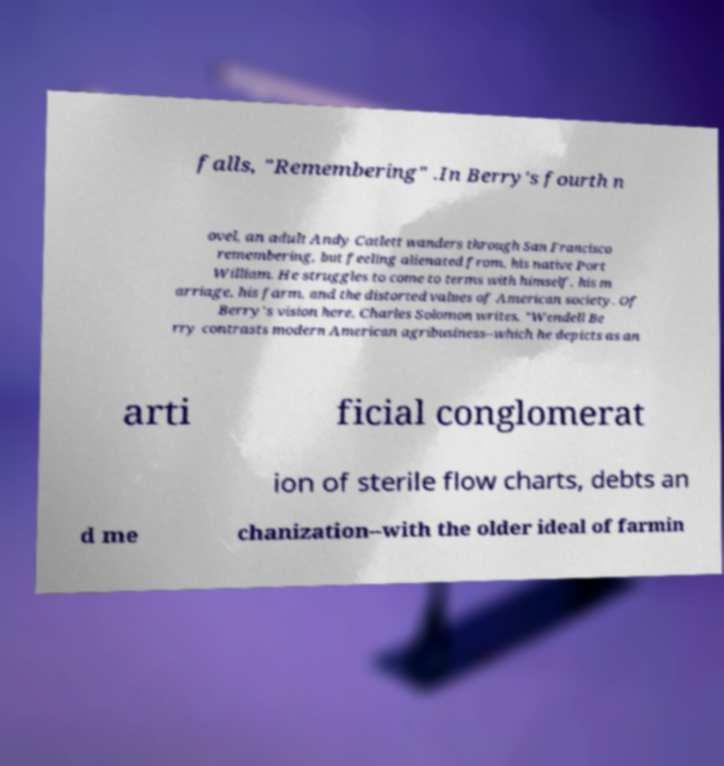Can you accurately transcribe the text from the provided image for me? falls, "Remembering" .In Berry's fourth n ovel, an adult Andy Catlett wanders through San Francisco remembering, but feeling alienated from, his native Port William. He struggles to come to terms with himself, his m arriage, his farm, and the distorted values of American society. Of Berry's vision here, Charles Solomon writes, "Wendell Be rry contrasts modern American agribusiness--which he depicts as an arti ficial conglomerat ion of sterile flow charts, debts an d me chanization--with the older ideal of farmin 